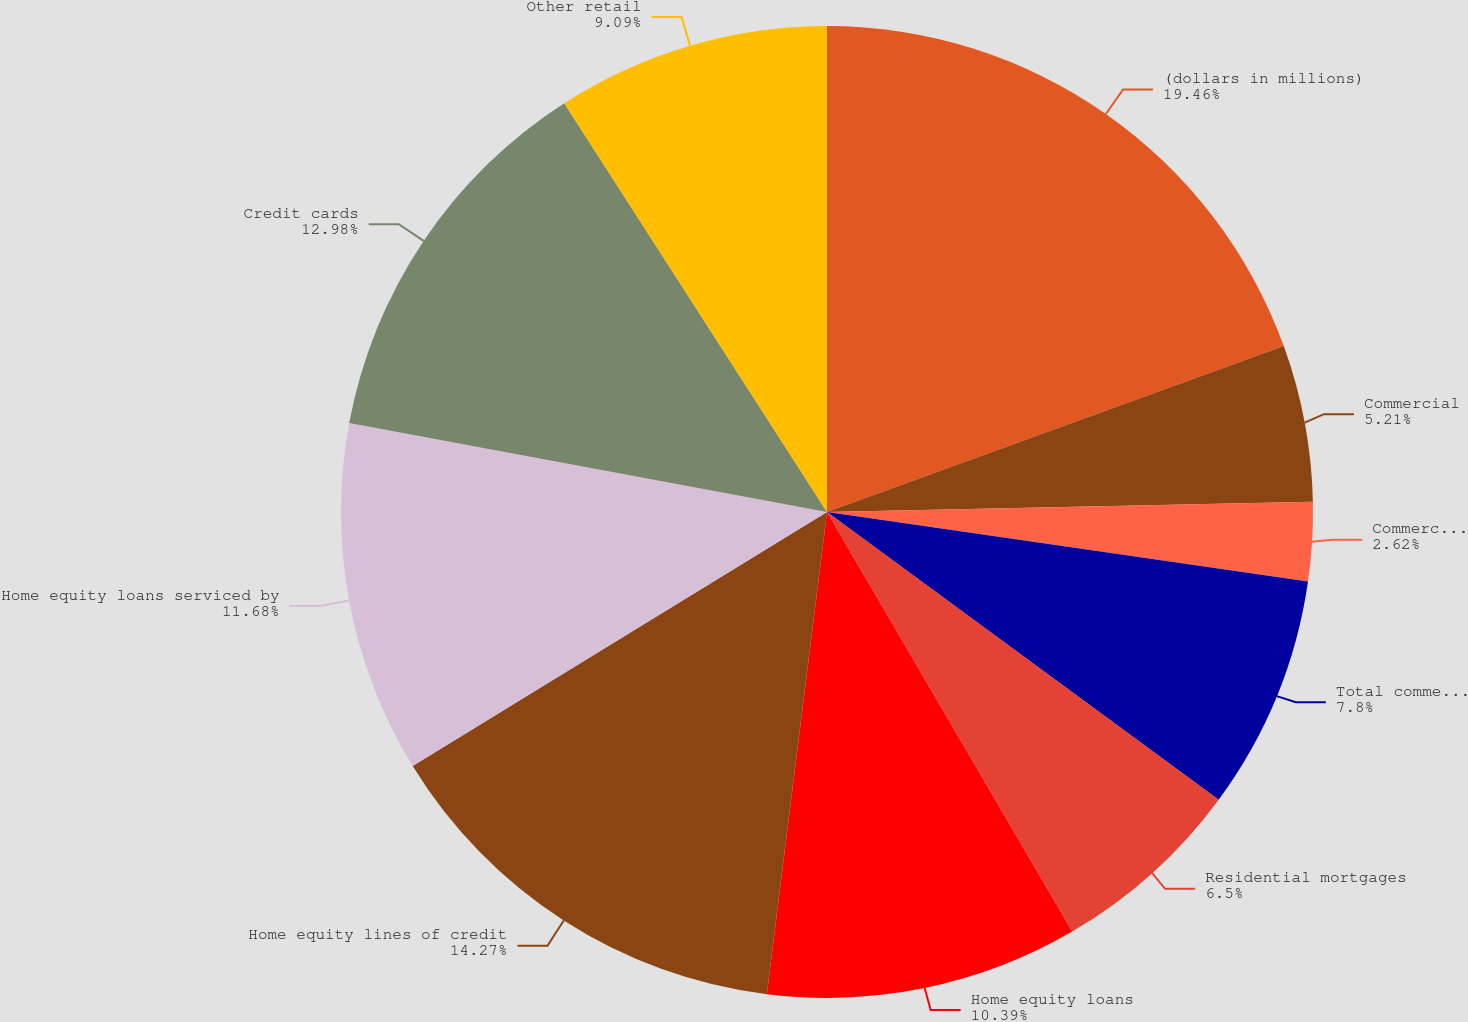Convert chart to OTSL. <chart><loc_0><loc_0><loc_500><loc_500><pie_chart><fcel>(dollars in millions)<fcel>Commercial<fcel>Commercial real estate<fcel>Total commercial<fcel>Residential mortgages<fcel>Home equity loans<fcel>Home equity lines of credit<fcel>Home equity loans serviced by<fcel>Credit cards<fcel>Other retail<nl><fcel>19.45%<fcel>5.21%<fcel>2.62%<fcel>7.8%<fcel>6.5%<fcel>10.39%<fcel>14.27%<fcel>11.68%<fcel>12.98%<fcel>9.09%<nl></chart> 